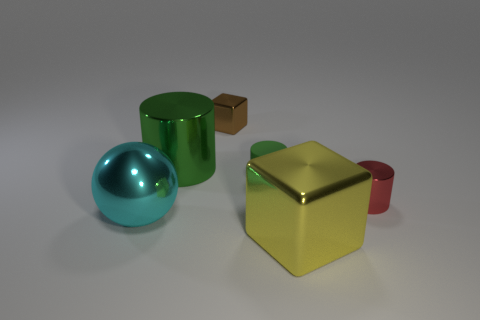Is there any other thing that is the same material as the yellow block?
Provide a short and direct response. Yes. What number of objects are either big shiny objects that are in front of the small red cylinder or tiny yellow blocks?
Give a very brief answer. 2. There is a thing behind the big thing behind the big sphere; is there a metallic cylinder on the left side of it?
Make the answer very short. Yes. How many tiny red rubber objects are there?
Offer a terse response. 0. How many things are either things to the left of the red thing or small cylinders that are behind the red cylinder?
Your answer should be very brief. 5. There is a block in front of the brown thing; does it have the same size as the large cyan metal sphere?
Your answer should be very brief. Yes. There is a green shiny object that is the same shape as the small green rubber thing; what is its size?
Your answer should be very brief. Large. There is a green cylinder that is the same size as the red cylinder; what is it made of?
Your answer should be compact. Rubber. There is a small red object that is the same shape as the small green matte thing; what is its material?
Keep it short and to the point. Metal. What number of other things are the same size as the green metal object?
Keep it short and to the point. 2. 